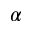Convert formula to latex. <formula><loc_0><loc_0><loc_500><loc_500>\alpha</formula> 